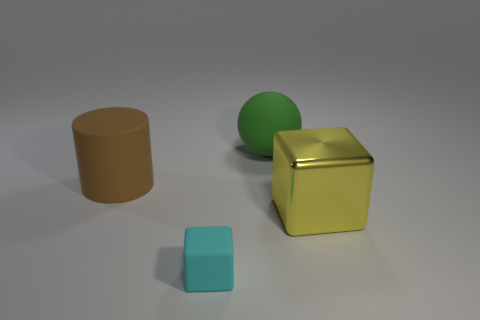Is there any other thing that has the same size as the matte block?
Your response must be concise. No. Are there fewer large blocks that are behind the big metal object than large cylinders that are in front of the large green matte thing?
Provide a succinct answer. Yes. What number of cubes are either big purple metal things or large brown things?
Offer a very short reply. 0. Are the large object that is behind the matte cylinder and the cyan cube right of the cylinder made of the same material?
Make the answer very short. Yes. There is a metal thing that is the same size as the rubber cylinder; what is its shape?
Keep it short and to the point. Cube. How many brown things are either tiny blocks or metallic things?
Offer a terse response. 0. Does the large matte thing behind the rubber cylinder have the same shape as the yellow metallic object in front of the large rubber ball?
Your response must be concise. No. How many other things are there of the same material as the yellow block?
Offer a terse response. 0. There is a large thing right of the green matte thing right of the brown rubber cylinder; are there any brown matte cylinders in front of it?
Make the answer very short. No. Is the material of the cyan thing the same as the large yellow block?
Your response must be concise. No. 